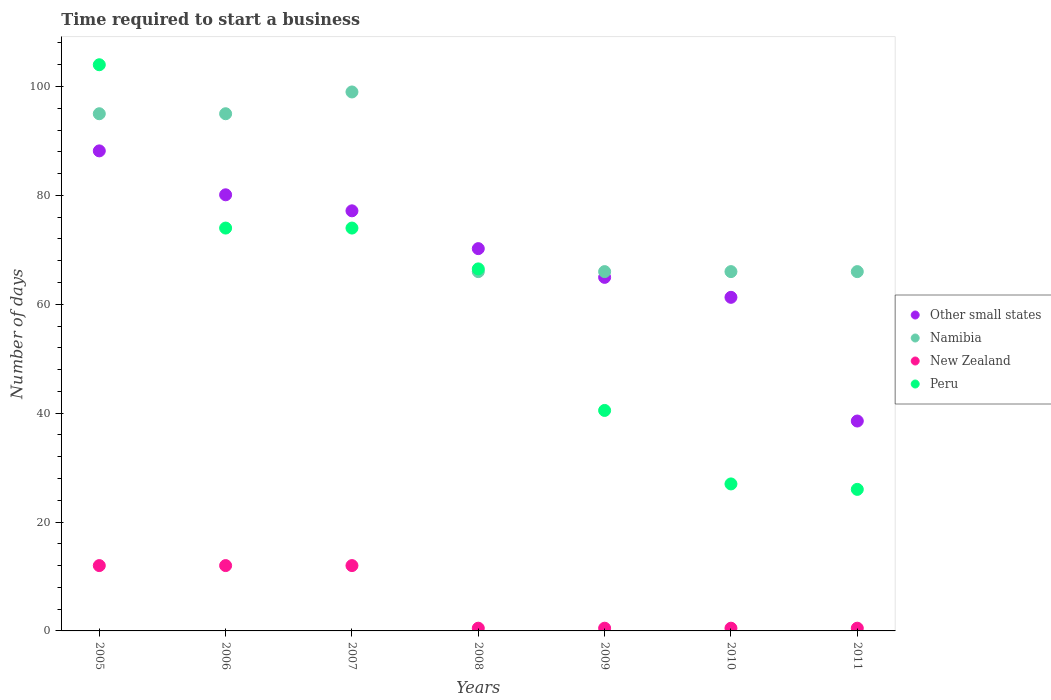What is the number of days required to start a business in Peru in 2007?
Your answer should be very brief. 74. Across all years, what is the maximum number of days required to start a business in New Zealand?
Give a very brief answer. 12. Across all years, what is the minimum number of days required to start a business in Other small states?
Offer a very short reply. 38.56. What is the total number of days required to start a business in Peru in the graph?
Offer a terse response. 412. What is the difference between the number of days required to start a business in Peru in 2005 and that in 2011?
Your response must be concise. 78. What is the difference between the number of days required to start a business in New Zealand in 2010 and the number of days required to start a business in Peru in 2009?
Your answer should be compact. -40. What is the average number of days required to start a business in Namibia per year?
Ensure brevity in your answer.  79. In the year 2009, what is the difference between the number of days required to start a business in Namibia and number of days required to start a business in Other small states?
Ensure brevity in your answer.  1.06. In how many years, is the number of days required to start a business in Namibia greater than 72 days?
Provide a short and direct response. 3. What is the ratio of the number of days required to start a business in Other small states in 2007 to that in 2010?
Provide a succinct answer. 1.26. Is the number of days required to start a business in Namibia in 2010 less than that in 2011?
Your answer should be compact. No. What is the difference between the highest and the second highest number of days required to start a business in New Zealand?
Your answer should be very brief. 0. In how many years, is the number of days required to start a business in New Zealand greater than the average number of days required to start a business in New Zealand taken over all years?
Make the answer very short. 3. Is the sum of the number of days required to start a business in Peru in 2005 and 2007 greater than the maximum number of days required to start a business in Namibia across all years?
Offer a terse response. Yes. Is it the case that in every year, the sum of the number of days required to start a business in Other small states and number of days required to start a business in Namibia  is greater than the sum of number of days required to start a business in New Zealand and number of days required to start a business in Peru?
Your answer should be compact. No. Is the number of days required to start a business in Peru strictly greater than the number of days required to start a business in Other small states over the years?
Your answer should be very brief. No. How many years are there in the graph?
Your answer should be very brief. 7. What is the difference between two consecutive major ticks on the Y-axis?
Keep it short and to the point. 20. Are the values on the major ticks of Y-axis written in scientific E-notation?
Provide a short and direct response. No. Does the graph contain any zero values?
Make the answer very short. No. How are the legend labels stacked?
Provide a succinct answer. Vertical. What is the title of the graph?
Provide a short and direct response. Time required to start a business. What is the label or title of the X-axis?
Your answer should be very brief. Years. What is the label or title of the Y-axis?
Keep it short and to the point. Number of days. What is the Number of days in Other small states in 2005?
Give a very brief answer. 88.18. What is the Number of days of New Zealand in 2005?
Keep it short and to the point. 12. What is the Number of days of Peru in 2005?
Ensure brevity in your answer.  104. What is the Number of days of Other small states in 2006?
Your answer should be compact. 80.11. What is the Number of days of Peru in 2006?
Give a very brief answer. 74. What is the Number of days of Other small states in 2007?
Your answer should be very brief. 77.17. What is the Number of days in Peru in 2007?
Offer a terse response. 74. What is the Number of days of Other small states in 2008?
Ensure brevity in your answer.  70.22. What is the Number of days in Namibia in 2008?
Give a very brief answer. 66. What is the Number of days of New Zealand in 2008?
Ensure brevity in your answer.  0.5. What is the Number of days in Peru in 2008?
Give a very brief answer. 66.5. What is the Number of days of Other small states in 2009?
Provide a short and direct response. 64.94. What is the Number of days in Peru in 2009?
Make the answer very short. 40.5. What is the Number of days of Other small states in 2010?
Offer a terse response. 61.28. What is the Number of days in Namibia in 2010?
Provide a succinct answer. 66. What is the Number of days of Peru in 2010?
Keep it short and to the point. 27. What is the Number of days in Other small states in 2011?
Your response must be concise. 38.56. Across all years, what is the maximum Number of days of Other small states?
Offer a terse response. 88.18. Across all years, what is the maximum Number of days of Namibia?
Offer a very short reply. 99. Across all years, what is the maximum Number of days of Peru?
Your answer should be very brief. 104. Across all years, what is the minimum Number of days of Other small states?
Ensure brevity in your answer.  38.56. Across all years, what is the minimum Number of days of Namibia?
Offer a very short reply. 66. What is the total Number of days in Other small states in the graph?
Your answer should be very brief. 480.45. What is the total Number of days of Namibia in the graph?
Offer a terse response. 553. What is the total Number of days in Peru in the graph?
Offer a terse response. 412. What is the difference between the Number of days in Other small states in 2005 and that in 2006?
Your answer should be compact. 8.07. What is the difference between the Number of days of Namibia in 2005 and that in 2006?
Provide a succinct answer. 0. What is the difference between the Number of days of Peru in 2005 and that in 2006?
Provide a succinct answer. 30. What is the difference between the Number of days in Other small states in 2005 and that in 2007?
Ensure brevity in your answer.  11.01. What is the difference between the Number of days of Namibia in 2005 and that in 2007?
Make the answer very short. -4. What is the difference between the Number of days of New Zealand in 2005 and that in 2007?
Keep it short and to the point. 0. What is the difference between the Number of days of Other small states in 2005 and that in 2008?
Your answer should be compact. 17.95. What is the difference between the Number of days of Namibia in 2005 and that in 2008?
Ensure brevity in your answer.  29. What is the difference between the Number of days of Peru in 2005 and that in 2008?
Offer a terse response. 37.5. What is the difference between the Number of days of Other small states in 2005 and that in 2009?
Keep it short and to the point. 23.23. What is the difference between the Number of days of New Zealand in 2005 and that in 2009?
Provide a succinct answer. 11.5. What is the difference between the Number of days in Peru in 2005 and that in 2009?
Your response must be concise. 63.5. What is the difference between the Number of days of Other small states in 2005 and that in 2010?
Your answer should be compact. 26.9. What is the difference between the Number of days in New Zealand in 2005 and that in 2010?
Your answer should be compact. 11.5. What is the difference between the Number of days of Peru in 2005 and that in 2010?
Give a very brief answer. 77. What is the difference between the Number of days in Other small states in 2005 and that in 2011?
Your response must be concise. 49.62. What is the difference between the Number of days in Namibia in 2005 and that in 2011?
Give a very brief answer. 29. What is the difference between the Number of days of New Zealand in 2005 and that in 2011?
Keep it short and to the point. 11.5. What is the difference between the Number of days in Peru in 2005 and that in 2011?
Keep it short and to the point. 78. What is the difference between the Number of days in Other small states in 2006 and that in 2007?
Provide a succinct answer. 2.94. What is the difference between the Number of days in Namibia in 2006 and that in 2007?
Your response must be concise. -4. What is the difference between the Number of days in New Zealand in 2006 and that in 2007?
Ensure brevity in your answer.  0. What is the difference between the Number of days in Other small states in 2006 and that in 2008?
Your answer should be compact. 9.89. What is the difference between the Number of days in Peru in 2006 and that in 2008?
Give a very brief answer. 7.5. What is the difference between the Number of days of Other small states in 2006 and that in 2009?
Provide a succinct answer. 15.17. What is the difference between the Number of days of Peru in 2006 and that in 2009?
Make the answer very short. 33.5. What is the difference between the Number of days of Other small states in 2006 and that in 2010?
Keep it short and to the point. 18.83. What is the difference between the Number of days in Other small states in 2006 and that in 2011?
Keep it short and to the point. 41.56. What is the difference between the Number of days in New Zealand in 2006 and that in 2011?
Offer a terse response. 11.5. What is the difference between the Number of days in Peru in 2006 and that in 2011?
Your response must be concise. 48. What is the difference between the Number of days of Other small states in 2007 and that in 2008?
Keep it short and to the point. 6.94. What is the difference between the Number of days in Namibia in 2007 and that in 2008?
Ensure brevity in your answer.  33. What is the difference between the Number of days of Peru in 2007 and that in 2008?
Provide a short and direct response. 7.5. What is the difference between the Number of days of Other small states in 2007 and that in 2009?
Make the answer very short. 12.22. What is the difference between the Number of days in New Zealand in 2007 and that in 2009?
Your answer should be very brief. 11.5. What is the difference between the Number of days in Peru in 2007 and that in 2009?
Keep it short and to the point. 33.5. What is the difference between the Number of days of Other small states in 2007 and that in 2010?
Provide a succinct answer. 15.89. What is the difference between the Number of days of New Zealand in 2007 and that in 2010?
Give a very brief answer. 11.5. What is the difference between the Number of days in Other small states in 2007 and that in 2011?
Offer a very short reply. 38.61. What is the difference between the Number of days of Other small states in 2008 and that in 2009?
Your answer should be very brief. 5.28. What is the difference between the Number of days of Namibia in 2008 and that in 2009?
Make the answer very short. 0. What is the difference between the Number of days of Other small states in 2008 and that in 2010?
Your response must be concise. 8.94. What is the difference between the Number of days of New Zealand in 2008 and that in 2010?
Your response must be concise. 0. What is the difference between the Number of days of Peru in 2008 and that in 2010?
Provide a succinct answer. 39.5. What is the difference between the Number of days in Other small states in 2008 and that in 2011?
Offer a very short reply. 31.67. What is the difference between the Number of days of New Zealand in 2008 and that in 2011?
Provide a short and direct response. 0. What is the difference between the Number of days in Peru in 2008 and that in 2011?
Your answer should be compact. 40.5. What is the difference between the Number of days of Other small states in 2009 and that in 2010?
Provide a short and direct response. 3.67. What is the difference between the Number of days of Other small states in 2009 and that in 2011?
Provide a succinct answer. 26.39. What is the difference between the Number of days of Namibia in 2009 and that in 2011?
Offer a very short reply. 0. What is the difference between the Number of days in New Zealand in 2009 and that in 2011?
Offer a very short reply. 0. What is the difference between the Number of days of Peru in 2009 and that in 2011?
Ensure brevity in your answer.  14.5. What is the difference between the Number of days in Other small states in 2010 and that in 2011?
Your response must be concise. 22.72. What is the difference between the Number of days in New Zealand in 2010 and that in 2011?
Your answer should be very brief. 0. What is the difference between the Number of days of Peru in 2010 and that in 2011?
Offer a very short reply. 1. What is the difference between the Number of days of Other small states in 2005 and the Number of days of Namibia in 2006?
Offer a terse response. -6.82. What is the difference between the Number of days in Other small states in 2005 and the Number of days in New Zealand in 2006?
Provide a succinct answer. 76.18. What is the difference between the Number of days of Other small states in 2005 and the Number of days of Peru in 2006?
Give a very brief answer. 14.18. What is the difference between the Number of days of Namibia in 2005 and the Number of days of New Zealand in 2006?
Your answer should be very brief. 83. What is the difference between the Number of days of Namibia in 2005 and the Number of days of Peru in 2006?
Provide a succinct answer. 21. What is the difference between the Number of days in New Zealand in 2005 and the Number of days in Peru in 2006?
Your response must be concise. -62. What is the difference between the Number of days of Other small states in 2005 and the Number of days of Namibia in 2007?
Offer a very short reply. -10.82. What is the difference between the Number of days of Other small states in 2005 and the Number of days of New Zealand in 2007?
Provide a succinct answer. 76.18. What is the difference between the Number of days of Other small states in 2005 and the Number of days of Peru in 2007?
Give a very brief answer. 14.18. What is the difference between the Number of days in Namibia in 2005 and the Number of days in Peru in 2007?
Offer a terse response. 21. What is the difference between the Number of days of New Zealand in 2005 and the Number of days of Peru in 2007?
Ensure brevity in your answer.  -62. What is the difference between the Number of days of Other small states in 2005 and the Number of days of Namibia in 2008?
Make the answer very short. 22.18. What is the difference between the Number of days in Other small states in 2005 and the Number of days in New Zealand in 2008?
Keep it short and to the point. 87.68. What is the difference between the Number of days of Other small states in 2005 and the Number of days of Peru in 2008?
Your answer should be compact. 21.68. What is the difference between the Number of days of Namibia in 2005 and the Number of days of New Zealand in 2008?
Keep it short and to the point. 94.5. What is the difference between the Number of days of Namibia in 2005 and the Number of days of Peru in 2008?
Ensure brevity in your answer.  28.5. What is the difference between the Number of days of New Zealand in 2005 and the Number of days of Peru in 2008?
Your answer should be very brief. -54.5. What is the difference between the Number of days of Other small states in 2005 and the Number of days of Namibia in 2009?
Your answer should be very brief. 22.18. What is the difference between the Number of days of Other small states in 2005 and the Number of days of New Zealand in 2009?
Provide a short and direct response. 87.68. What is the difference between the Number of days in Other small states in 2005 and the Number of days in Peru in 2009?
Make the answer very short. 47.68. What is the difference between the Number of days of Namibia in 2005 and the Number of days of New Zealand in 2009?
Your answer should be very brief. 94.5. What is the difference between the Number of days of Namibia in 2005 and the Number of days of Peru in 2009?
Give a very brief answer. 54.5. What is the difference between the Number of days of New Zealand in 2005 and the Number of days of Peru in 2009?
Keep it short and to the point. -28.5. What is the difference between the Number of days in Other small states in 2005 and the Number of days in Namibia in 2010?
Ensure brevity in your answer.  22.18. What is the difference between the Number of days in Other small states in 2005 and the Number of days in New Zealand in 2010?
Offer a terse response. 87.68. What is the difference between the Number of days of Other small states in 2005 and the Number of days of Peru in 2010?
Provide a succinct answer. 61.18. What is the difference between the Number of days in Namibia in 2005 and the Number of days in New Zealand in 2010?
Give a very brief answer. 94.5. What is the difference between the Number of days in New Zealand in 2005 and the Number of days in Peru in 2010?
Offer a very short reply. -15. What is the difference between the Number of days in Other small states in 2005 and the Number of days in Namibia in 2011?
Provide a short and direct response. 22.18. What is the difference between the Number of days in Other small states in 2005 and the Number of days in New Zealand in 2011?
Give a very brief answer. 87.68. What is the difference between the Number of days of Other small states in 2005 and the Number of days of Peru in 2011?
Your answer should be very brief. 62.18. What is the difference between the Number of days in Namibia in 2005 and the Number of days in New Zealand in 2011?
Your answer should be very brief. 94.5. What is the difference between the Number of days of Namibia in 2005 and the Number of days of Peru in 2011?
Your answer should be very brief. 69. What is the difference between the Number of days in Other small states in 2006 and the Number of days in Namibia in 2007?
Provide a succinct answer. -18.89. What is the difference between the Number of days of Other small states in 2006 and the Number of days of New Zealand in 2007?
Offer a very short reply. 68.11. What is the difference between the Number of days of Other small states in 2006 and the Number of days of Peru in 2007?
Provide a succinct answer. 6.11. What is the difference between the Number of days of Namibia in 2006 and the Number of days of New Zealand in 2007?
Your answer should be compact. 83. What is the difference between the Number of days in New Zealand in 2006 and the Number of days in Peru in 2007?
Your response must be concise. -62. What is the difference between the Number of days in Other small states in 2006 and the Number of days in Namibia in 2008?
Offer a very short reply. 14.11. What is the difference between the Number of days in Other small states in 2006 and the Number of days in New Zealand in 2008?
Provide a short and direct response. 79.61. What is the difference between the Number of days in Other small states in 2006 and the Number of days in Peru in 2008?
Keep it short and to the point. 13.61. What is the difference between the Number of days in Namibia in 2006 and the Number of days in New Zealand in 2008?
Provide a succinct answer. 94.5. What is the difference between the Number of days of Namibia in 2006 and the Number of days of Peru in 2008?
Make the answer very short. 28.5. What is the difference between the Number of days of New Zealand in 2006 and the Number of days of Peru in 2008?
Your answer should be very brief. -54.5. What is the difference between the Number of days in Other small states in 2006 and the Number of days in Namibia in 2009?
Provide a succinct answer. 14.11. What is the difference between the Number of days of Other small states in 2006 and the Number of days of New Zealand in 2009?
Your answer should be compact. 79.61. What is the difference between the Number of days in Other small states in 2006 and the Number of days in Peru in 2009?
Make the answer very short. 39.61. What is the difference between the Number of days of Namibia in 2006 and the Number of days of New Zealand in 2009?
Provide a short and direct response. 94.5. What is the difference between the Number of days of Namibia in 2006 and the Number of days of Peru in 2009?
Your answer should be very brief. 54.5. What is the difference between the Number of days of New Zealand in 2006 and the Number of days of Peru in 2009?
Make the answer very short. -28.5. What is the difference between the Number of days of Other small states in 2006 and the Number of days of Namibia in 2010?
Keep it short and to the point. 14.11. What is the difference between the Number of days of Other small states in 2006 and the Number of days of New Zealand in 2010?
Offer a very short reply. 79.61. What is the difference between the Number of days in Other small states in 2006 and the Number of days in Peru in 2010?
Offer a very short reply. 53.11. What is the difference between the Number of days in Namibia in 2006 and the Number of days in New Zealand in 2010?
Provide a succinct answer. 94.5. What is the difference between the Number of days of Namibia in 2006 and the Number of days of Peru in 2010?
Offer a very short reply. 68. What is the difference between the Number of days in Other small states in 2006 and the Number of days in Namibia in 2011?
Your answer should be very brief. 14.11. What is the difference between the Number of days in Other small states in 2006 and the Number of days in New Zealand in 2011?
Give a very brief answer. 79.61. What is the difference between the Number of days of Other small states in 2006 and the Number of days of Peru in 2011?
Make the answer very short. 54.11. What is the difference between the Number of days in Namibia in 2006 and the Number of days in New Zealand in 2011?
Give a very brief answer. 94.5. What is the difference between the Number of days of New Zealand in 2006 and the Number of days of Peru in 2011?
Make the answer very short. -14. What is the difference between the Number of days in Other small states in 2007 and the Number of days in Namibia in 2008?
Provide a short and direct response. 11.17. What is the difference between the Number of days in Other small states in 2007 and the Number of days in New Zealand in 2008?
Keep it short and to the point. 76.67. What is the difference between the Number of days in Other small states in 2007 and the Number of days in Peru in 2008?
Your answer should be very brief. 10.67. What is the difference between the Number of days in Namibia in 2007 and the Number of days in New Zealand in 2008?
Provide a short and direct response. 98.5. What is the difference between the Number of days in Namibia in 2007 and the Number of days in Peru in 2008?
Your answer should be very brief. 32.5. What is the difference between the Number of days of New Zealand in 2007 and the Number of days of Peru in 2008?
Provide a succinct answer. -54.5. What is the difference between the Number of days in Other small states in 2007 and the Number of days in Namibia in 2009?
Your answer should be very brief. 11.17. What is the difference between the Number of days of Other small states in 2007 and the Number of days of New Zealand in 2009?
Give a very brief answer. 76.67. What is the difference between the Number of days of Other small states in 2007 and the Number of days of Peru in 2009?
Offer a very short reply. 36.67. What is the difference between the Number of days in Namibia in 2007 and the Number of days in New Zealand in 2009?
Keep it short and to the point. 98.5. What is the difference between the Number of days of Namibia in 2007 and the Number of days of Peru in 2009?
Ensure brevity in your answer.  58.5. What is the difference between the Number of days of New Zealand in 2007 and the Number of days of Peru in 2009?
Offer a terse response. -28.5. What is the difference between the Number of days in Other small states in 2007 and the Number of days in Namibia in 2010?
Your answer should be compact. 11.17. What is the difference between the Number of days in Other small states in 2007 and the Number of days in New Zealand in 2010?
Make the answer very short. 76.67. What is the difference between the Number of days of Other small states in 2007 and the Number of days of Peru in 2010?
Keep it short and to the point. 50.17. What is the difference between the Number of days in Namibia in 2007 and the Number of days in New Zealand in 2010?
Your answer should be compact. 98.5. What is the difference between the Number of days in Namibia in 2007 and the Number of days in Peru in 2010?
Keep it short and to the point. 72. What is the difference between the Number of days of Other small states in 2007 and the Number of days of Namibia in 2011?
Give a very brief answer. 11.17. What is the difference between the Number of days in Other small states in 2007 and the Number of days in New Zealand in 2011?
Keep it short and to the point. 76.67. What is the difference between the Number of days of Other small states in 2007 and the Number of days of Peru in 2011?
Provide a succinct answer. 51.17. What is the difference between the Number of days in Namibia in 2007 and the Number of days in New Zealand in 2011?
Provide a short and direct response. 98.5. What is the difference between the Number of days in Namibia in 2007 and the Number of days in Peru in 2011?
Provide a succinct answer. 73. What is the difference between the Number of days of Other small states in 2008 and the Number of days of Namibia in 2009?
Your answer should be compact. 4.22. What is the difference between the Number of days in Other small states in 2008 and the Number of days in New Zealand in 2009?
Give a very brief answer. 69.72. What is the difference between the Number of days in Other small states in 2008 and the Number of days in Peru in 2009?
Keep it short and to the point. 29.72. What is the difference between the Number of days in Namibia in 2008 and the Number of days in New Zealand in 2009?
Make the answer very short. 65.5. What is the difference between the Number of days of Namibia in 2008 and the Number of days of Peru in 2009?
Provide a short and direct response. 25.5. What is the difference between the Number of days of Other small states in 2008 and the Number of days of Namibia in 2010?
Make the answer very short. 4.22. What is the difference between the Number of days in Other small states in 2008 and the Number of days in New Zealand in 2010?
Keep it short and to the point. 69.72. What is the difference between the Number of days in Other small states in 2008 and the Number of days in Peru in 2010?
Your answer should be compact. 43.22. What is the difference between the Number of days in Namibia in 2008 and the Number of days in New Zealand in 2010?
Provide a succinct answer. 65.5. What is the difference between the Number of days of Namibia in 2008 and the Number of days of Peru in 2010?
Keep it short and to the point. 39. What is the difference between the Number of days in New Zealand in 2008 and the Number of days in Peru in 2010?
Ensure brevity in your answer.  -26.5. What is the difference between the Number of days of Other small states in 2008 and the Number of days of Namibia in 2011?
Make the answer very short. 4.22. What is the difference between the Number of days of Other small states in 2008 and the Number of days of New Zealand in 2011?
Provide a succinct answer. 69.72. What is the difference between the Number of days of Other small states in 2008 and the Number of days of Peru in 2011?
Ensure brevity in your answer.  44.22. What is the difference between the Number of days of Namibia in 2008 and the Number of days of New Zealand in 2011?
Keep it short and to the point. 65.5. What is the difference between the Number of days of New Zealand in 2008 and the Number of days of Peru in 2011?
Keep it short and to the point. -25.5. What is the difference between the Number of days in Other small states in 2009 and the Number of days in Namibia in 2010?
Ensure brevity in your answer.  -1.06. What is the difference between the Number of days in Other small states in 2009 and the Number of days in New Zealand in 2010?
Ensure brevity in your answer.  64.44. What is the difference between the Number of days of Other small states in 2009 and the Number of days of Peru in 2010?
Provide a succinct answer. 37.94. What is the difference between the Number of days in Namibia in 2009 and the Number of days in New Zealand in 2010?
Provide a succinct answer. 65.5. What is the difference between the Number of days in New Zealand in 2009 and the Number of days in Peru in 2010?
Offer a very short reply. -26.5. What is the difference between the Number of days of Other small states in 2009 and the Number of days of Namibia in 2011?
Your answer should be very brief. -1.06. What is the difference between the Number of days in Other small states in 2009 and the Number of days in New Zealand in 2011?
Your answer should be very brief. 64.44. What is the difference between the Number of days in Other small states in 2009 and the Number of days in Peru in 2011?
Your response must be concise. 38.94. What is the difference between the Number of days in Namibia in 2009 and the Number of days in New Zealand in 2011?
Offer a very short reply. 65.5. What is the difference between the Number of days in Namibia in 2009 and the Number of days in Peru in 2011?
Your answer should be compact. 40. What is the difference between the Number of days in New Zealand in 2009 and the Number of days in Peru in 2011?
Your response must be concise. -25.5. What is the difference between the Number of days of Other small states in 2010 and the Number of days of Namibia in 2011?
Your answer should be very brief. -4.72. What is the difference between the Number of days of Other small states in 2010 and the Number of days of New Zealand in 2011?
Offer a terse response. 60.78. What is the difference between the Number of days in Other small states in 2010 and the Number of days in Peru in 2011?
Make the answer very short. 35.28. What is the difference between the Number of days of Namibia in 2010 and the Number of days of New Zealand in 2011?
Provide a succinct answer. 65.5. What is the difference between the Number of days in Namibia in 2010 and the Number of days in Peru in 2011?
Offer a terse response. 40. What is the difference between the Number of days in New Zealand in 2010 and the Number of days in Peru in 2011?
Provide a short and direct response. -25.5. What is the average Number of days of Other small states per year?
Provide a short and direct response. 68.64. What is the average Number of days in Namibia per year?
Keep it short and to the point. 79. What is the average Number of days of New Zealand per year?
Provide a short and direct response. 5.43. What is the average Number of days in Peru per year?
Offer a terse response. 58.86. In the year 2005, what is the difference between the Number of days of Other small states and Number of days of Namibia?
Offer a very short reply. -6.82. In the year 2005, what is the difference between the Number of days in Other small states and Number of days in New Zealand?
Offer a terse response. 76.18. In the year 2005, what is the difference between the Number of days of Other small states and Number of days of Peru?
Keep it short and to the point. -15.82. In the year 2005, what is the difference between the Number of days of Namibia and Number of days of New Zealand?
Keep it short and to the point. 83. In the year 2005, what is the difference between the Number of days of Namibia and Number of days of Peru?
Ensure brevity in your answer.  -9. In the year 2005, what is the difference between the Number of days of New Zealand and Number of days of Peru?
Provide a succinct answer. -92. In the year 2006, what is the difference between the Number of days of Other small states and Number of days of Namibia?
Provide a short and direct response. -14.89. In the year 2006, what is the difference between the Number of days of Other small states and Number of days of New Zealand?
Ensure brevity in your answer.  68.11. In the year 2006, what is the difference between the Number of days in Other small states and Number of days in Peru?
Provide a short and direct response. 6.11. In the year 2006, what is the difference between the Number of days in Namibia and Number of days in New Zealand?
Keep it short and to the point. 83. In the year 2006, what is the difference between the Number of days in Namibia and Number of days in Peru?
Offer a very short reply. 21. In the year 2006, what is the difference between the Number of days of New Zealand and Number of days of Peru?
Offer a very short reply. -62. In the year 2007, what is the difference between the Number of days of Other small states and Number of days of Namibia?
Your response must be concise. -21.83. In the year 2007, what is the difference between the Number of days in Other small states and Number of days in New Zealand?
Give a very brief answer. 65.17. In the year 2007, what is the difference between the Number of days in Other small states and Number of days in Peru?
Provide a short and direct response. 3.17. In the year 2007, what is the difference between the Number of days of Namibia and Number of days of Peru?
Ensure brevity in your answer.  25. In the year 2007, what is the difference between the Number of days of New Zealand and Number of days of Peru?
Offer a very short reply. -62. In the year 2008, what is the difference between the Number of days in Other small states and Number of days in Namibia?
Your answer should be compact. 4.22. In the year 2008, what is the difference between the Number of days of Other small states and Number of days of New Zealand?
Your answer should be very brief. 69.72. In the year 2008, what is the difference between the Number of days of Other small states and Number of days of Peru?
Your answer should be very brief. 3.72. In the year 2008, what is the difference between the Number of days of Namibia and Number of days of New Zealand?
Ensure brevity in your answer.  65.5. In the year 2008, what is the difference between the Number of days in Namibia and Number of days in Peru?
Make the answer very short. -0.5. In the year 2008, what is the difference between the Number of days in New Zealand and Number of days in Peru?
Ensure brevity in your answer.  -66. In the year 2009, what is the difference between the Number of days of Other small states and Number of days of Namibia?
Your answer should be compact. -1.06. In the year 2009, what is the difference between the Number of days in Other small states and Number of days in New Zealand?
Make the answer very short. 64.44. In the year 2009, what is the difference between the Number of days of Other small states and Number of days of Peru?
Your answer should be very brief. 24.44. In the year 2009, what is the difference between the Number of days in Namibia and Number of days in New Zealand?
Keep it short and to the point. 65.5. In the year 2009, what is the difference between the Number of days of Namibia and Number of days of Peru?
Your answer should be very brief. 25.5. In the year 2010, what is the difference between the Number of days of Other small states and Number of days of Namibia?
Give a very brief answer. -4.72. In the year 2010, what is the difference between the Number of days of Other small states and Number of days of New Zealand?
Offer a very short reply. 60.78. In the year 2010, what is the difference between the Number of days of Other small states and Number of days of Peru?
Your answer should be compact. 34.28. In the year 2010, what is the difference between the Number of days in Namibia and Number of days in New Zealand?
Your answer should be very brief. 65.5. In the year 2010, what is the difference between the Number of days in Namibia and Number of days in Peru?
Keep it short and to the point. 39. In the year 2010, what is the difference between the Number of days in New Zealand and Number of days in Peru?
Your answer should be very brief. -26.5. In the year 2011, what is the difference between the Number of days in Other small states and Number of days in Namibia?
Offer a very short reply. -27.44. In the year 2011, what is the difference between the Number of days of Other small states and Number of days of New Zealand?
Your response must be concise. 38.06. In the year 2011, what is the difference between the Number of days of Other small states and Number of days of Peru?
Offer a terse response. 12.56. In the year 2011, what is the difference between the Number of days in Namibia and Number of days in New Zealand?
Ensure brevity in your answer.  65.5. In the year 2011, what is the difference between the Number of days in Namibia and Number of days in Peru?
Offer a terse response. 40. In the year 2011, what is the difference between the Number of days in New Zealand and Number of days in Peru?
Your response must be concise. -25.5. What is the ratio of the Number of days in Other small states in 2005 to that in 2006?
Offer a very short reply. 1.1. What is the ratio of the Number of days in Peru in 2005 to that in 2006?
Provide a succinct answer. 1.41. What is the ratio of the Number of days of Other small states in 2005 to that in 2007?
Give a very brief answer. 1.14. What is the ratio of the Number of days in Namibia in 2005 to that in 2007?
Give a very brief answer. 0.96. What is the ratio of the Number of days of New Zealand in 2005 to that in 2007?
Ensure brevity in your answer.  1. What is the ratio of the Number of days of Peru in 2005 to that in 2007?
Provide a short and direct response. 1.41. What is the ratio of the Number of days in Other small states in 2005 to that in 2008?
Give a very brief answer. 1.26. What is the ratio of the Number of days in Namibia in 2005 to that in 2008?
Provide a short and direct response. 1.44. What is the ratio of the Number of days of Peru in 2005 to that in 2008?
Make the answer very short. 1.56. What is the ratio of the Number of days of Other small states in 2005 to that in 2009?
Your response must be concise. 1.36. What is the ratio of the Number of days of Namibia in 2005 to that in 2009?
Make the answer very short. 1.44. What is the ratio of the Number of days of New Zealand in 2005 to that in 2009?
Provide a short and direct response. 24. What is the ratio of the Number of days of Peru in 2005 to that in 2009?
Provide a short and direct response. 2.57. What is the ratio of the Number of days of Other small states in 2005 to that in 2010?
Your answer should be very brief. 1.44. What is the ratio of the Number of days in Namibia in 2005 to that in 2010?
Your answer should be compact. 1.44. What is the ratio of the Number of days of Peru in 2005 to that in 2010?
Offer a very short reply. 3.85. What is the ratio of the Number of days of Other small states in 2005 to that in 2011?
Provide a short and direct response. 2.29. What is the ratio of the Number of days of Namibia in 2005 to that in 2011?
Offer a very short reply. 1.44. What is the ratio of the Number of days in New Zealand in 2005 to that in 2011?
Keep it short and to the point. 24. What is the ratio of the Number of days of Peru in 2005 to that in 2011?
Give a very brief answer. 4. What is the ratio of the Number of days in Other small states in 2006 to that in 2007?
Your answer should be very brief. 1.04. What is the ratio of the Number of days in Namibia in 2006 to that in 2007?
Keep it short and to the point. 0.96. What is the ratio of the Number of days of New Zealand in 2006 to that in 2007?
Offer a very short reply. 1. What is the ratio of the Number of days of Other small states in 2006 to that in 2008?
Provide a succinct answer. 1.14. What is the ratio of the Number of days in Namibia in 2006 to that in 2008?
Your answer should be compact. 1.44. What is the ratio of the Number of days of Peru in 2006 to that in 2008?
Ensure brevity in your answer.  1.11. What is the ratio of the Number of days in Other small states in 2006 to that in 2009?
Provide a short and direct response. 1.23. What is the ratio of the Number of days in Namibia in 2006 to that in 2009?
Provide a succinct answer. 1.44. What is the ratio of the Number of days in New Zealand in 2006 to that in 2009?
Your answer should be very brief. 24. What is the ratio of the Number of days of Peru in 2006 to that in 2009?
Your answer should be compact. 1.83. What is the ratio of the Number of days in Other small states in 2006 to that in 2010?
Your answer should be compact. 1.31. What is the ratio of the Number of days in Namibia in 2006 to that in 2010?
Make the answer very short. 1.44. What is the ratio of the Number of days of New Zealand in 2006 to that in 2010?
Keep it short and to the point. 24. What is the ratio of the Number of days of Peru in 2006 to that in 2010?
Offer a very short reply. 2.74. What is the ratio of the Number of days in Other small states in 2006 to that in 2011?
Ensure brevity in your answer.  2.08. What is the ratio of the Number of days in Namibia in 2006 to that in 2011?
Your answer should be compact. 1.44. What is the ratio of the Number of days in New Zealand in 2006 to that in 2011?
Provide a succinct answer. 24. What is the ratio of the Number of days in Peru in 2006 to that in 2011?
Make the answer very short. 2.85. What is the ratio of the Number of days of Other small states in 2007 to that in 2008?
Offer a very short reply. 1.1. What is the ratio of the Number of days in Peru in 2007 to that in 2008?
Your answer should be very brief. 1.11. What is the ratio of the Number of days of Other small states in 2007 to that in 2009?
Keep it short and to the point. 1.19. What is the ratio of the Number of days in Namibia in 2007 to that in 2009?
Provide a succinct answer. 1.5. What is the ratio of the Number of days of Peru in 2007 to that in 2009?
Make the answer very short. 1.83. What is the ratio of the Number of days in Other small states in 2007 to that in 2010?
Give a very brief answer. 1.26. What is the ratio of the Number of days of Namibia in 2007 to that in 2010?
Your response must be concise. 1.5. What is the ratio of the Number of days in Peru in 2007 to that in 2010?
Offer a terse response. 2.74. What is the ratio of the Number of days of Other small states in 2007 to that in 2011?
Offer a very short reply. 2. What is the ratio of the Number of days in New Zealand in 2007 to that in 2011?
Your answer should be very brief. 24. What is the ratio of the Number of days in Peru in 2007 to that in 2011?
Your answer should be compact. 2.85. What is the ratio of the Number of days in Other small states in 2008 to that in 2009?
Give a very brief answer. 1.08. What is the ratio of the Number of days in Namibia in 2008 to that in 2009?
Offer a very short reply. 1. What is the ratio of the Number of days of Peru in 2008 to that in 2009?
Provide a succinct answer. 1.64. What is the ratio of the Number of days of Other small states in 2008 to that in 2010?
Keep it short and to the point. 1.15. What is the ratio of the Number of days in Peru in 2008 to that in 2010?
Provide a succinct answer. 2.46. What is the ratio of the Number of days of Other small states in 2008 to that in 2011?
Ensure brevity in your answer.  1.82. What is the ratio of the Number of days of Namibia in 2008 to that in 2011?
Keep it short and to the point. 1. What is the ratio of the Number of days of New Zealand in 2008 to that in 2011?
Keep it short and to the point. 1. What is the ratio of the Number of days in Peru in 2008 to that in 2011?
Your answer should be very brief. 2.56. What is the ratio of the Number of days in Other small states in 2009 to that in 2010?
Your response must be concise. 1.06. What is the ratio of the Number of days of New Zealand in 2009 to that in 2010?
Your answer should be compact. 1. What is the ratio of the Number of days of Other small states in 2009 to that in 2011?
Ensure brevity in your answer.  1.68. What is the ratio of the Number of days in Peru in 2009 to that in 2011?
Provide a succinct answer. 1.56. What is the ratio of the Number of days in Other small states in 2010 to that in 2011?
Make the answer very short. 1.59. What is the ratio of the Number of days of Namibia in 2010 to that in 2011?
Your answer should be compact. 1. What is the ratio of the Number of days in New Zealand in 2010 to that in 2011?
Make the answer very short. 1. What is the difference between the highest and the second highest Number of days of Other small states?
Keep it short and to the point. 8.07. What is the difference between the highest and the second highest Number of days in Namibia?
Ensure brevity in your answer.  4. What is the difference between the highest and the lowest Number of days in Other small states?
Your answer should be very brief. 49.62. What is the difference between the highest and the lowest Number of days in New Zealand?
Your answer should be compact. 11.5. 